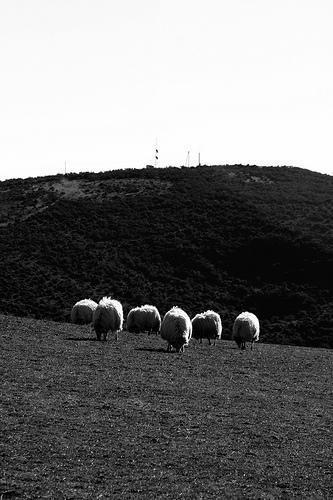How many sheep are in the photo?
Give a very brief answer. 6. 